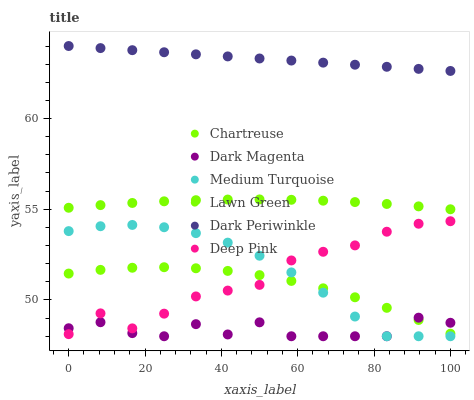Does Dark Magenta have the minimum area under the curve?
Answer yes or no. Yes. Does Dark Periwinkle have the maximum area under the curve?
Answer yes or no. Yes. Does Deep Pink have the minimum area under the curve?
Answer yes or no. No. Does Deep Pink have the maximum area under the curve?
Answer yes or no. No. Is Dark Periwinkle the smoothest?
Answer yes or no. Yes. Is Dark Magenta the roughest?
Answer yes or no. Yes. Is Deep Pink the smoothest?
Answer yes or no. No. Is Deep Pink the roughest?
Answer yes or no. No. Does Dark Magenta have the lowest value?
Answer yes or no. Yes. Does Deep Pink have the lowest value?
Answer yes or no. No. Does Dark Periwinkle have the highest value?
Answer yes or no. Yes. Does Deep Pink have the highest value?
Answer yes or no. No. Is Chartreuse less than Lawn Green?
Answer yes or no. Yes. Is Lawn Green greater than Deep Pink?
Answer yes or no. Yes. Does Deep Pink intersect Chartreuse?
Answer yes or no. Yes. Is Deep Pink less than Chartreuse?
Answer yes or no. No. Is Deep Pink greater than Chartreuse?
Answer yes or no. No. Does Chartreuse intersect Lawn Green?
Answer yes or no. No. 